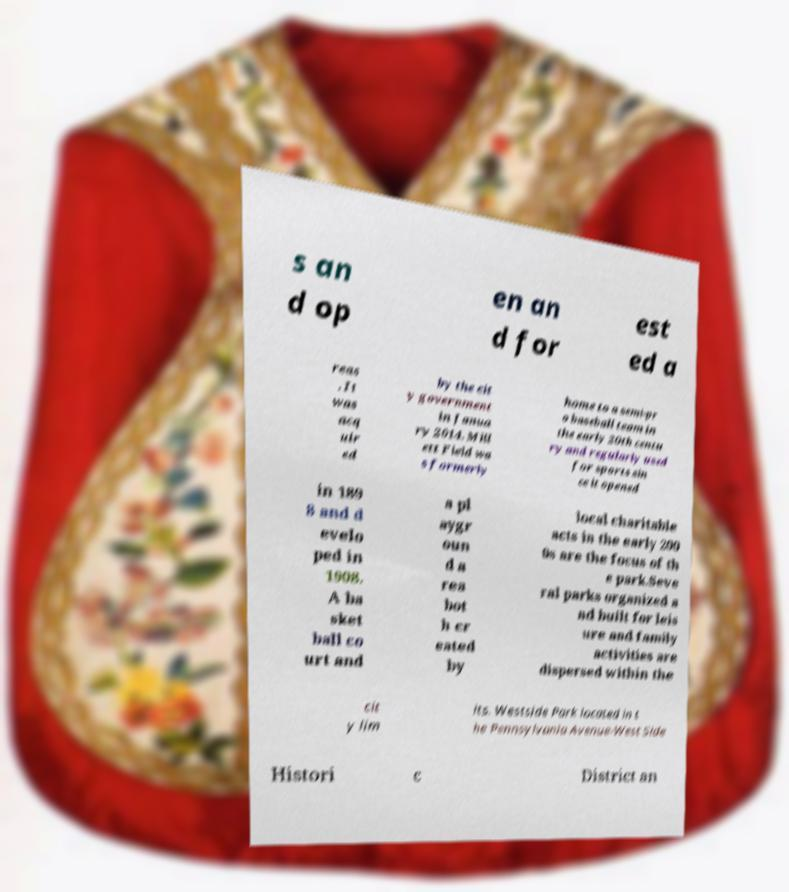There's text embedded in this image that I need extracted. Can you transcribe it verbatim? s an d op en an d for est ed a reas . It was acq uir ed by the cit y government in Janua ry 2014. Mill ett Field wa s formerly home to a semi-pr o baseball team in the early 20th centu ry and regularly used for sports sin ce it opened in 189 8 and d evelo ped in 1908. A ba sket ball co urt and a pl aygr oun d a rea bot h cr eated by local charitable acts in the early 200 0s are the focus of th e park.Seve ral parks organized a nd built for leis ure and family activities are dispersed within the cit y lim its. Westside Park located in t he Pennsylvania Avenue-West Side Histori c District an 